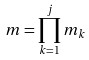Convert formula to latex. <formula><loc_0><loc_0><loc_500><loc_500>m = \prod _ { k = 1 } ^ { j } m _ { k }</formula> 